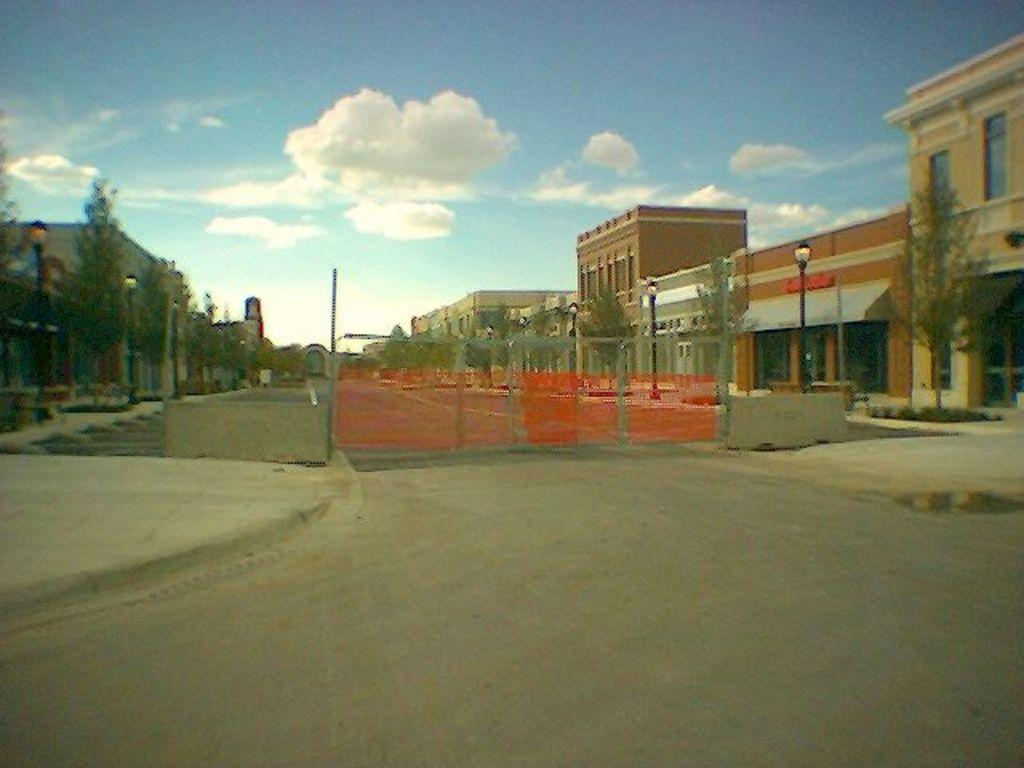What can be seen in the sky in the image? The sky with clouds is visible in the image. What type of structures are present in the image? There are buildings in the image. What type of vegetation is present in the image? Trees are present in the image. What type of urban infrastructure is visible in the image? Street poles and street lights are visible in the image. What type of pathway is present in the image? There is a road in the image. What type of barrier is visible in the image? A fence is visible in the image. What type of art can be seen on the side of the road in the image? There is no art visible on the side of the road in the image. How much milk is being poured from the street light in the image? There is no milk present in the image, and therefore no such activity can be observed. 